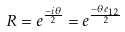<formula> <loc_0><loc_0><loc_500><loc_500>R = e ^ { \frac { - i \theta } { 2 } } = e ^ { \frac { - \theta e _ { 1 2 } } { 2 } }</formula> 